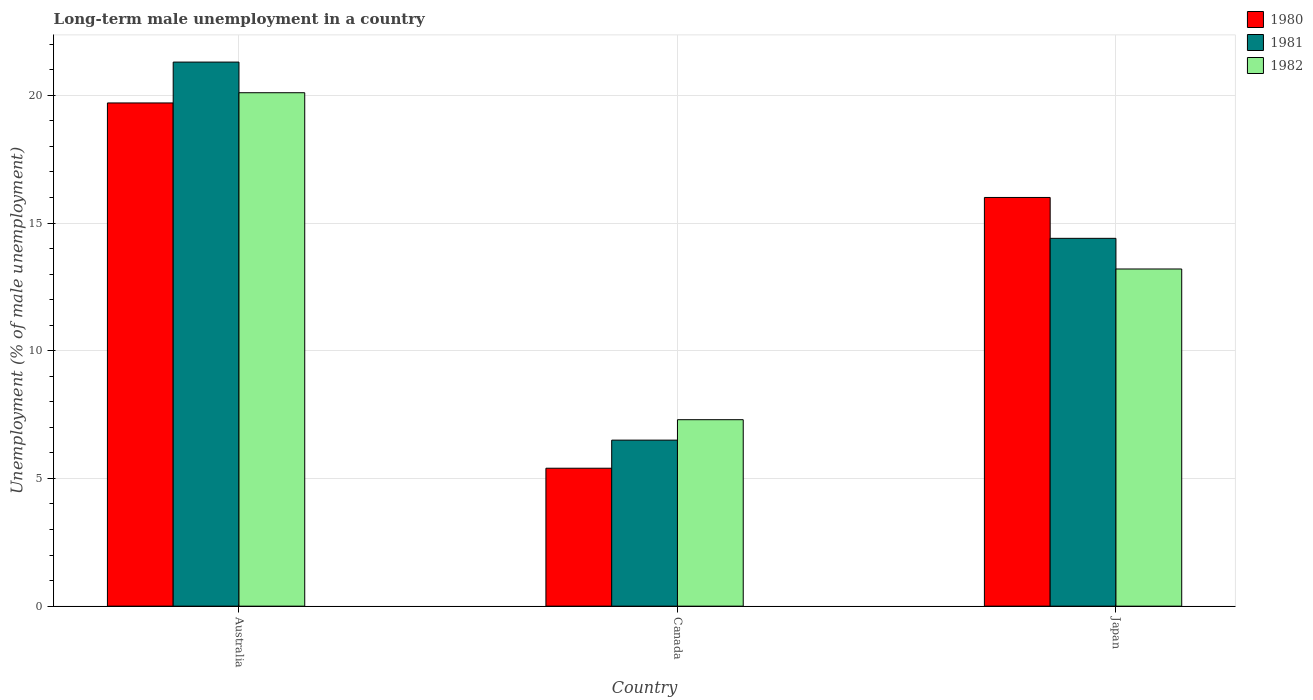What is the percentage of long-term unemployed male population in 1982 in Canada?
Offer a very short reply. 7.3. Across all countries, what is the maximum percentage of long-term unemployed male population in 1982?
Your answer should be compact. 20.1. Across all countries, what is the minimum percentage of long-term unemployed male population in 1982?
Keep it short and to the point. 7.3. In which country was the percentage of long-term unemployed male population in 1980 minimum?
Offer a terse response. Canada. What is the total percentage of long-term unemployed male population in 1981 in the graph?
Make the answer very short. 42.2. What is the difference between the percentage of long-term unemployed male population in 1980 in Australia and that in Japan?
Ensure brevity in your answer.  3.7. What is the difference between the percentage of long-term unemployed male population in 1980 in Canada and the percentage of long-term unemployed male population in 1981 in Japan?
Keep it short and to the point. -9. What is the average percentage of long-term unemployed male population in 1982 per country?
Keep it short and to the point. 13.53. What is the difference between the percentage of long-term unemployed male population of/in 1982 and percentage of long-term unemployed male population of/in 1981 in Japan?
Provide a short and direct response. -1.2. What is the ratio of the percentage of long-term unemployed male population in 1981 in Canada to that in Japan?
Offer a terse response. 0.45. Is the percentage of long-term unemployed male population in 1980 in Canada less than that in Japan?
Make the answer very short. Yes. Is the difference between the percentage of long-term unemployed male population in 1982 in Australia and Japan greater than the difference between the percentage of long-term unemployed male population in 1981 in Australia and Japan?
Your answer should be very brief. Yes. What is the difference between the highest and the second highest percentage of long-term unemployed male population in 1982?
Your answer should be very brief. 6.9. What is the difference between the highest and the lowest percentage of long-term unemployed male population in 1981?
Offer a terse response. 14.8. In how many countries, is the percentage of long-term unemployed male population in 1982 greater than the average percentage of long-term unemployed male population in 1982 taken over all countries?
Your answer should be very brief. 1. Is the sum of the percentage of long-term unemployed male population in 1981 in Canada and Japan greater than the maximum percentage of long-term unemployed male population in 1980 across all countries?
Provide a short and direct response. Yes. What does the 2nd bar from the left in Canada represents?
Provide a short and direct response. 1981. What does the 2nd bar from the right in Canada represents?
Your response must be concise. 1981. Is it the case that in every country, the sum of the percentage of long-term unemployed male population in 1980 and percentage of long-term unemployed male population in 1982 is greater than the percentage of long-term unemployed male population in 1981?
Give a very brief answer. Yes. Are all the bars in the graph horizontal?
Your answer should be very brief. No. How many countries are there in the graph?
Provide a short and direct response. 3. What is the difference between two consecutive major ticks on the Y-axis?
Offer a terse response. 5. Does the graph contain any zero values?
Offer a terse response. No. How are the legend labels stacked?
Your answer should be compact. Vertical. What is the title of the graph?
Offer a terse response. Long-term male unemployment in a country. Does "1988" appear as one of the legend labels in the graph?
Make the answer very short. No. What is the label or title of the Y-axis?
Provide a succinct answer. Unemployment (% of male unemployment). What is the Unemployment (% of male unemployment) in 1980 in Australia?
Make the answer very short. 19.7. What is the Unemployment (% of male unemployment) in 1981 in Australia?
Your answer should be compact. 21.3. What is the Unemployment (% of male unemployment) in 1982 in Australia?
Ensure brevity in your answer.  20.1. What is the Unemployment (% of male unemployment) in 1980 in Canada?
Make the answer very short. 5.4. What is the Unemployment (% of male unemployment) of 1982 in Canada?
Keep it short and to the point. 7.3. What is the Unemployment (% of male unemployment) in 1980 in Japan?
Ensure brevity in your answer.  16. What is the Unemployment (% of male unemployment) in 1981 in Japan?
Ensure brevity in your answer.  14.4. What is the Unemployment (% of male unemployment) in 1982 in Japan?
Provide a succinct answer. 13.2. Across all countries, what is the maximum Unemployment (% of male unemployment) in 1980?
Provide a short and direct response. 19.7. Across all countries, what is the maximum Unemployment (% of male unemployment) of 1981?
Your response must be concise. 21.3. Across all countries, what is the maximum Unemployment (% of male unemployment) in 1982?
Your answer should be very brief. 20.1. Across all countries, what is the minimum Unemployment (% of male unemployment) of 1980?
Your response must be concise. 5.4. Across all countries, what is the minimum Unemployment (% of male unemployment) in 1981?
Offer a terse response. 6.5. Across all countries, what is the minimum Unemployment (% of male unemployment) of 1982?
Your answer should be compact. 7.3. What is the total Unemployment (% of male unemployment) of 1980 in the graph?
Offer a very short reply. 41.1. What is the total Unemployment (% of male unemployment) of 1981 in the graph?
Ensure brevity in your answer.  42.2. What is the total Unemployment (% of male unemployment) in 1982 in the graph?
Your response must be concise. 40.6. What is the difference between the Unemployment (% of male unemployment) of 1980 in Australia and that in Canada?
Provide a short and direct response. 14.3. What is the difference between the Unemployment (% of male unemployment) of 1982 in Australia and that in Canada?
Provide a succinct answer. 12.8. What is the difference between the Unemployment (% of male unemployment) of 1980 in Australia and that in Japan?
Ensure brevity in your answer.  3.7. What is the difference between the Unemployment (% of male unemployment) in 1982 in Australia and that in Japan?
Ensure brevity in your answer.  6.9. What is the difference between the Unemployment (% of male unemployment) of 1980 in Canada and that in Japan?
Your answer should be compact. -10.6. What is the difference between the Unemployment (% of male unemployment) of 1982 in Canada and that in Japan?
Provide a short and direct response. -5.9. What is the difference between the Unemployment (% of male unemployment) in 1980 in Australia and the Unemployment (% of male unemployment) in 1981 in Canada?
Your answer should be compact. 13.2. What is the difference between the Unemployment (% of male unemployment) of 1981 in Australia and the Unemployment (% of male unemployment) of 1982 in Canada?
Offer a very short reply. 14. What is the difference between the Unemployment (% of male unemployment) in 1980 in Australia and the Unemployment (% of male unemployment) in 1981 in Japan?
Your answer should be very brief. 5.3. What is the difference between the Unemployment (% of male unemployment) in 1980 in Australia and the Unemployment (% of male unemployment) in 1982 in Japan?
Give a very brief answer. 6.5. What is the difference between the Unemployment (% of male unemployment) in 1980 in Canada and the Unemployment (% of male unemployment) in 1981 in Japan?
Ensure brevity in your answer.  -9. What is the difference between the Unemployment (% of male unemployment) of 1980 in Canada and the Unemployment (% of male unemployment) of 1982 in Japan?
Keep it short and to the point. -7.8. What is the difference between the Unemployment (% of male unemployment) of 1981 in Canada and the Unemployment (% of male unemployment) of 1982 in Japan?
Give a very brief answer. -6.7. What is the average Unemployment (% of male unemployment) in 1980 per country?
Provide a short and direct response. 13.7. What is the average Unemployment (% of male unemployment) in 1981 per country?
Your response must be concise. 14.07. What is the average Unemployment (% of male unemployment) in 1982 per country?
Your answer should be compact. 13.53. What is the difference between the Unemployment (% of male unemployment) in 1980 and Unemployment (% of male unemployment) in 1982 in Australia?
Keep it short and to the point. -0.4. What is the difference between the Unemployment (% of male unemployment) in 1981 and Unemployment (% of male unemployment) in 1982 in Australia?
Keep it short and to the point. 1.2. What is the difference between the Unemployment (% of male unemployment) of 1980 and Unemployment (% of male unemployment) of 1981 in Canada?
Your answer should be compact. -1.1. What is the difference between the Unemployment (% of male unemployment) in 1981 and Unemployment (% of male unemployment) in 1982 in Canada?
Make the answer very short. -0.8. What is the ratio of the Unemployment (% of male unemployment) of 1980 in Australia to that in Canada?
Keep it short and to the point. 3.65. What is the ratio of the Unemployment (% of male unemployment) of 1981 in Australia to that in Canada?
Keep it short and to the point. 3.28. What is the ratio of the Unemployment (% of male unemployment) of 1982 in Australia to that in Canada?
Make the answer very short. 2.75. What is the ratio of the Unemployment (% of male unemployment) of 1980 in Australia to that in Japan?
Provide a short and direct response. 1.23. What is the ratio of the Unemployment (% of male unemployment) of 1981 in Australia to that in Japan?
Keep it short and to the point. 1.48. What is the ratio of the Unemployment (% of male unemployment) of 1982 in Australia to that in Japan?
Offer a very short reply. 1.52. What is the ratio of the Unemployment (% of male unemployment) of 1980 in Canada to that in Japan?
Your response must be concise. 0.34. What is the ratio of the Unemployment (% of male unemployment) of 1981 in Canada to that in Japan?
Provide a succinct answer. 0.45. What is the ratio of the Unemployment (% of male unemployment) in 1982 in Canada to that in Japan?
Offer a very short reply. 0.55. What is the difference between the highest and the second highest Unemployment (% of male unemployment) in 1981?
Keep it short and to the point. 6.9. What is the difference between the highest and the lowest Unemployment (% of male unemployment) of 1980?
Give a very brief answer. 14.3. What is the difference between the highest and the lowest Unemployment (% of male unemployment) in 1981?
Offer a terse response. 14.8. 